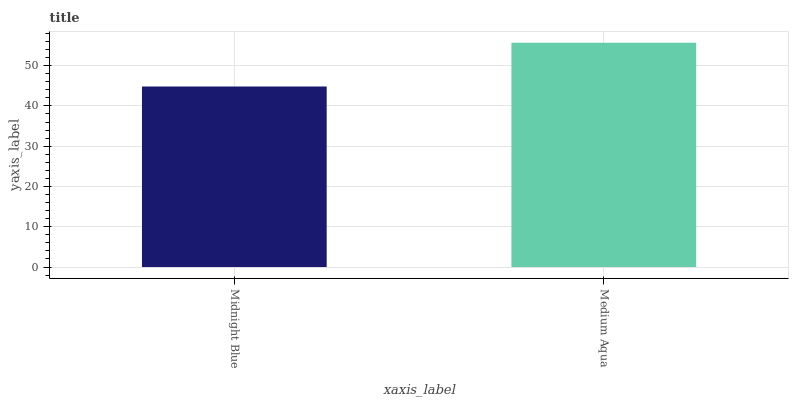Is Midnight Blue the minimum?
Answer yes or no. Yes. Is Medium Aqua the maximum?
Answer yes or no. Yes. Is Medium Aqua the minimum?
Answer yes or no. No. Is Medium Aqua greater than Midnight Blue?
Answer yes or no. Yes. Is Midnight Blue less than Medium Aqua?
Answer yes or no. Yes. Is Midnight Blue greater than Medium Aqua?
Answer yes or no. No. Is Medium Aqua less than Midnight Blue?
Answer yes or no. No. Is Medium Aqua the high median?
Answer yes or no. Yes. Is Midnight Blue the low median?
Answer yes or no. Yes. Is Midnight Blue the high median?
Answer yes or no. No. Is Medium Aqua the low median?
Answer yes or no. No. 